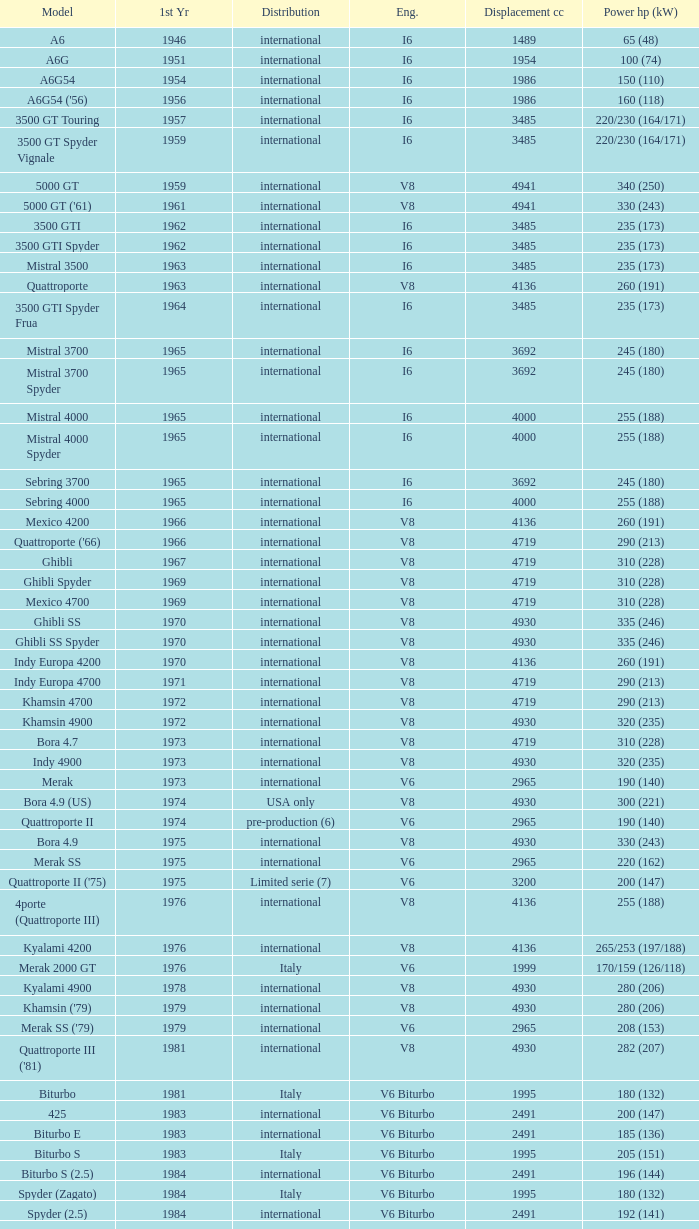What is the total number of First Year, when Displacement CC is greater than 4719, when Engine is V8, when Power HP (kW) is "335 (246)", and when Model is "Ghibli SS"? 1.0. 